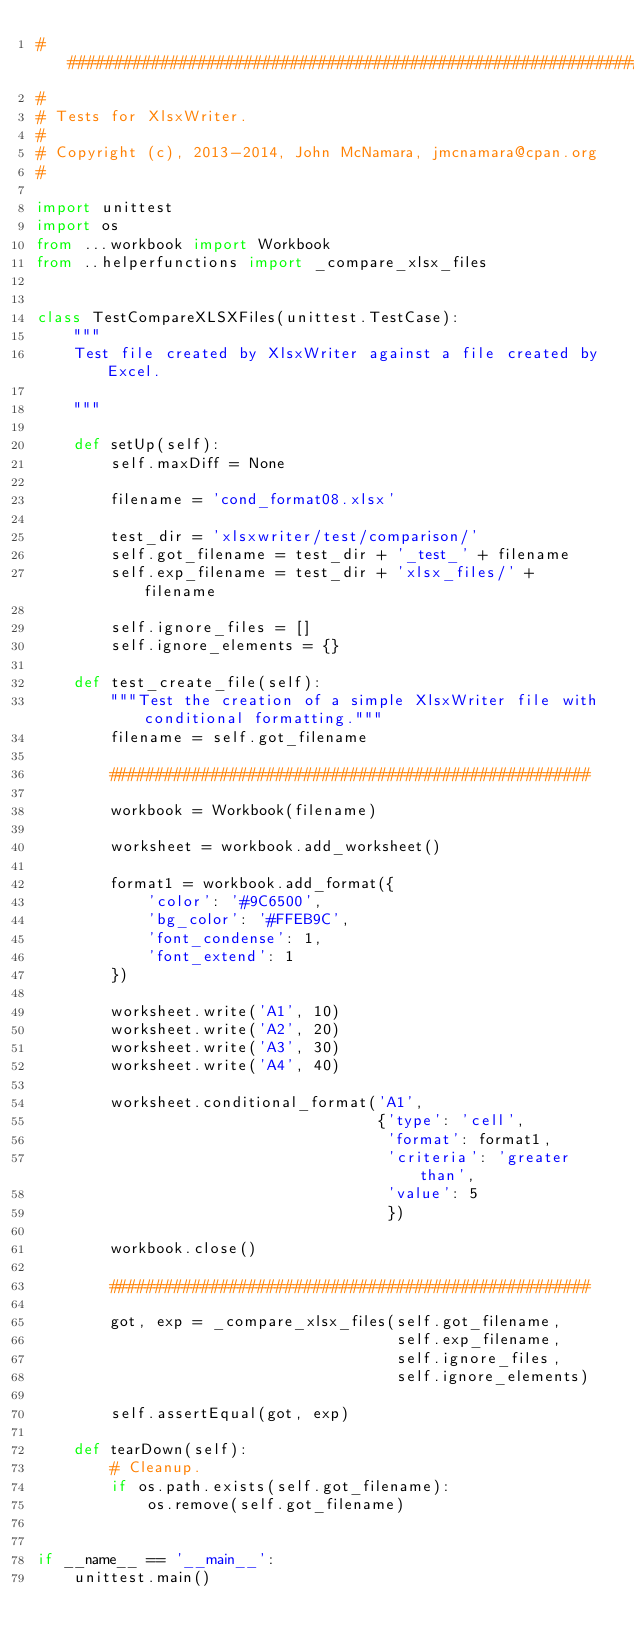<code> <loc_0><loc_0><loc_500><loc_500><_Python_>###############################################################################
#
# Tests for XlsxWriter.
#
# Copyright (c), 2013-2014, John McNamara, jmcnamara@cpan.org
#

import unittest
import os
from ...workbook import Workbook
from ..helperfunctions import _compare_xlsx_files


class TestCompareXLSXFiles(unittest.TestCase):
    """
    Test file created by XlsxWriter against a file created by Excel.

    """

    def setUp(self):
        self.maxDiff = None

        filename = 'cond_format08.xlsx'

        test_dir = 'xlsxwriter/test/comparison/'
        self.got_filename = test_dir + '_test_' + filename
        self.exp_filename = test_dir + 'xlsx_files/' + filename

        self.ignore_files = []
        self.ignore_elements = {}

    def test_create_file(self):
        """Test the creation of a simple XlsxWriter file with conditional formatting."""
        filename = self.got_filename

        ####################################################

        workbook = Workbook(filename)

        worksheet = workbook.add_worksheet()

        format1 = workbook.add_format({
            'color': '#9C6500',
            'bg_color': '#FFEB9C',
            'font_condense': 1,
            'font_extend': 1
        })

        worksheet.write('A1', 10)
        worksheet.write('A2', 20)
        worksheet.write('A3', 30)
        worksheet.write('A4', 40)

        worksheet.conditional_format('A1',
                                     {'type': 'cell',
                                      'format': format1,
                                      'criteria': 'greater than',
                                      'value': 5
                                      })

        workbook.close()

        ####################################################

        got, exp = _compare_xlsx_files(self.got_filename,
                                       self.exp_filename,
                                       self.ignore_files,
                                       self.ignore_elements)

        self.assertEqual(got, exp)

    def tearDown(self):
        # Cleanup.
        if os.path.exists(self.got_filename):
            os.remove(self.got_filename)


if __name__ == '__main__':
    unittest.main()
</code> 